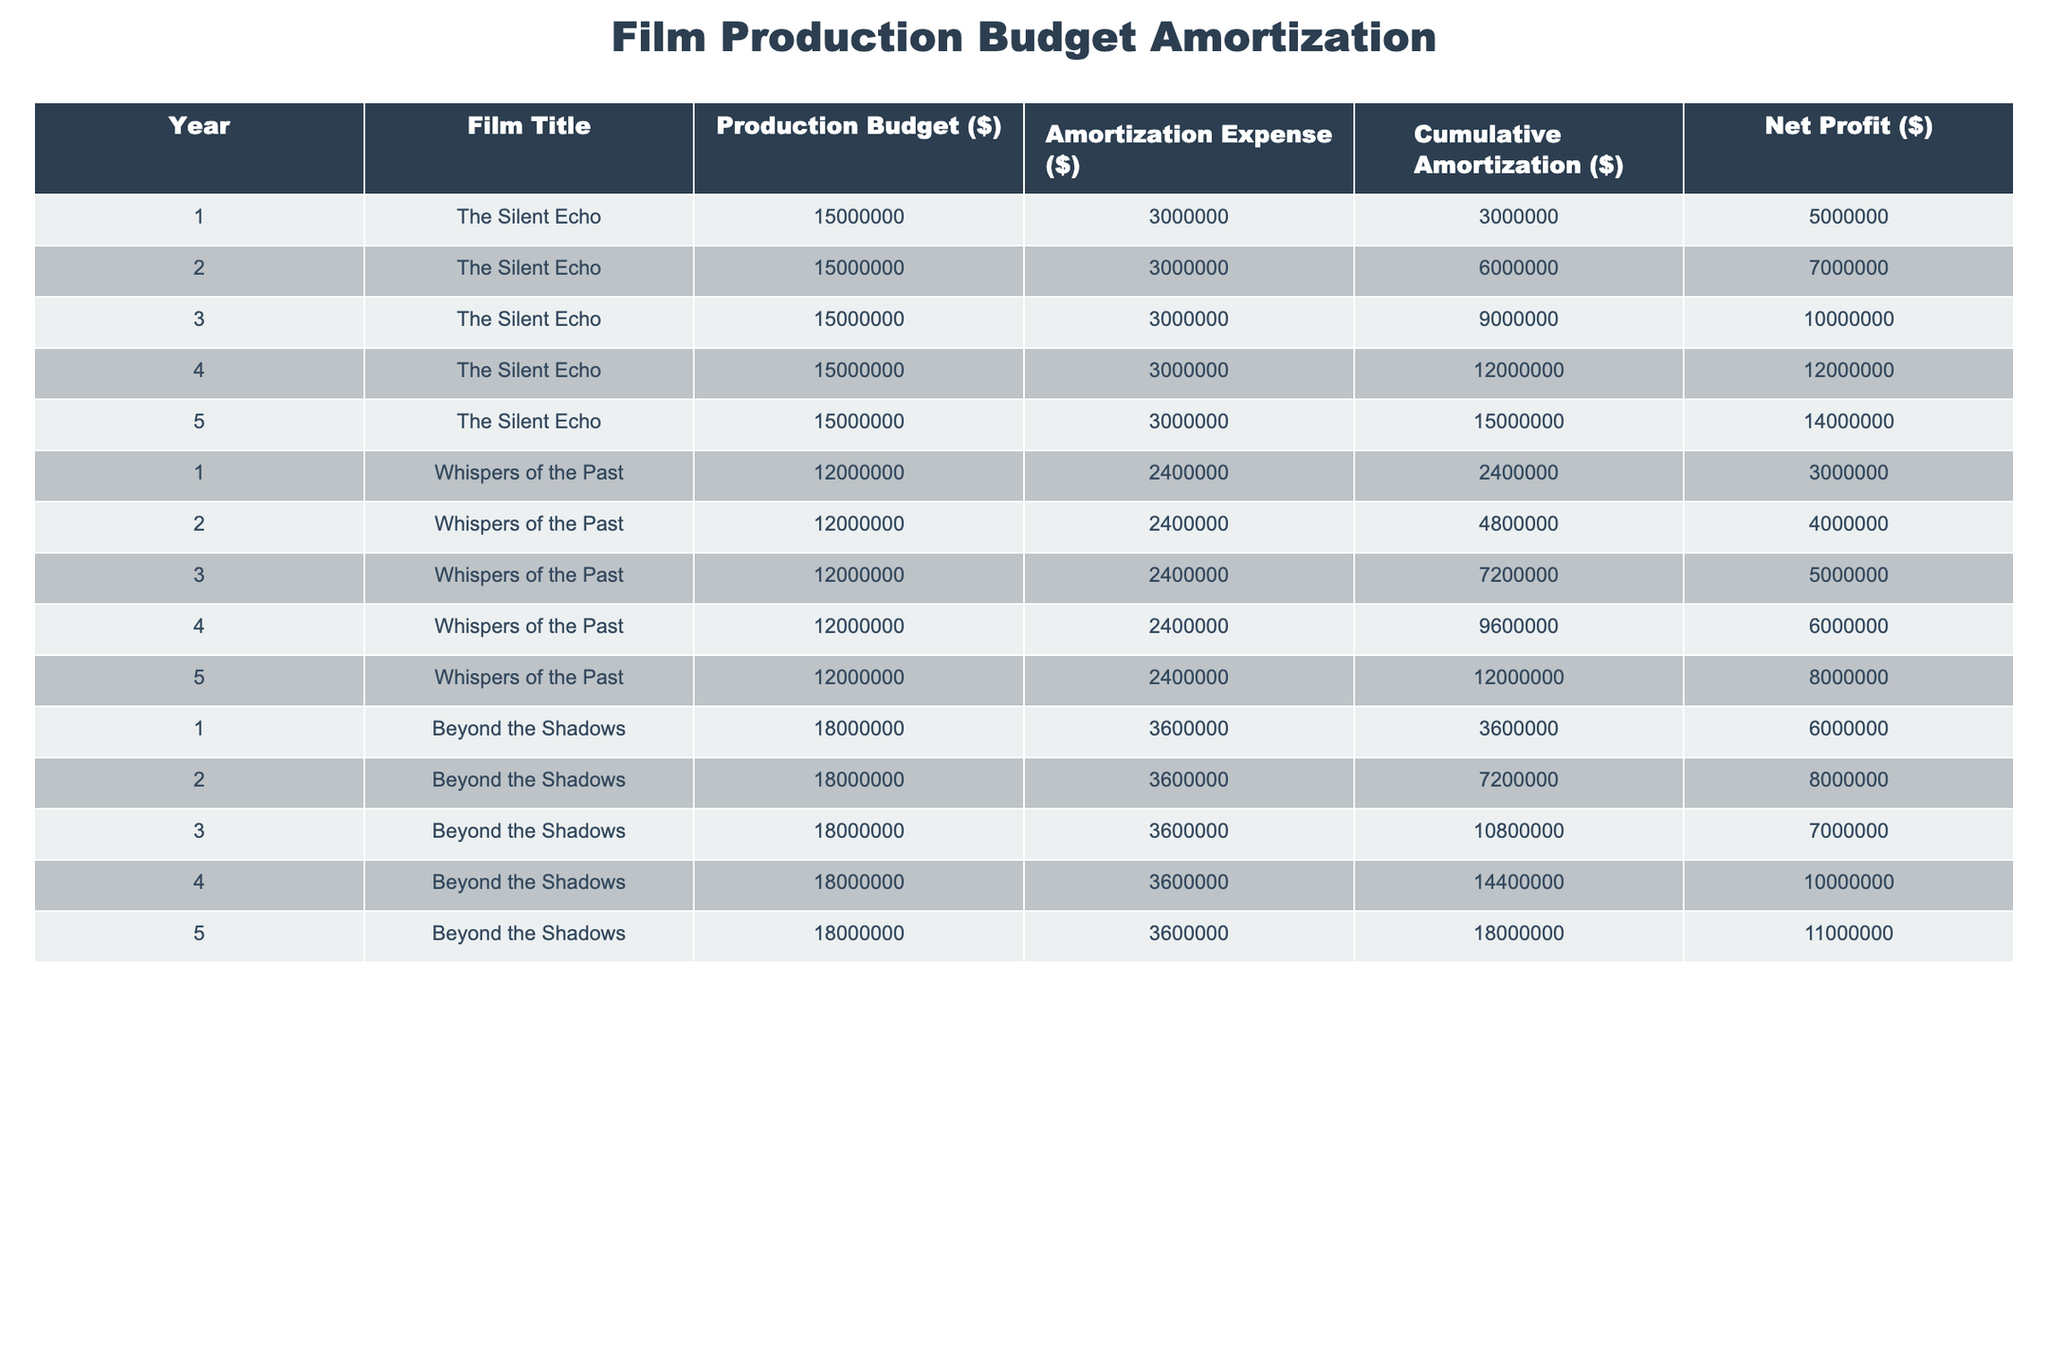What is the total production budget for "The Silent Echo"? The production budget for "The Silent Echo" is consistently $15,000,000 for each of the 5 years. Hence, the total production budget is simply $15,000,000.
Answer: 15000000 In which year did "Whispers of the Past" have the highest cumulative amortization? The cumulative amortization for "Whispers of the Past" increases each year. It reaches its highest value of $12,000,000 in year 5.
Answer: 5 What is the average net profit for the three movies over the 5-year period? Adding the net profits of all three films: "The Silent Echo" ($14,000,000) + "Whispers of the Past" ($8,000,000) + "Beyond the Shadows" ($11,000,000) gives a total of $33,000,000. Dividing by the three films (33,000,000 / 3) gives an average of $11,000,000.
Answer: 11000000 Was the net profit of "Beyond the Shadows" greater than that of "The Silent Echo" in any year? The net profit for "Beyond the Shadows" is $6,000,000 in year 1 and $8,000,000 in year 2, which is less than "The Silent Echo", but it reaches $11,000,000 in year 4, which is greater than "The Silent Echo", which is $12,000,000 in year 4 and $14,000,000 in year 5. Therefore, there were years where its profit was less than, but also one where it surpassed "The Silent Echo".
Answer: Yes What is the total amortization expense for "Whispers of the Past" over 5 years? The amortization expense for "Whispers of the Past" is $2,400,000 each year for 5 years, so multiplying gives us a total of $2,400,000 x 5 = $12,000,000.
Answer: 12000000 In which year did the amortization expense first exceed $3,000,000? The amortization expense for "The Silent Echo" is $3,000,000 starting from year 1 and continues for all subsequent years. Therefore, it first exceeds $3,000,000 in year 1.
Answer: 1 